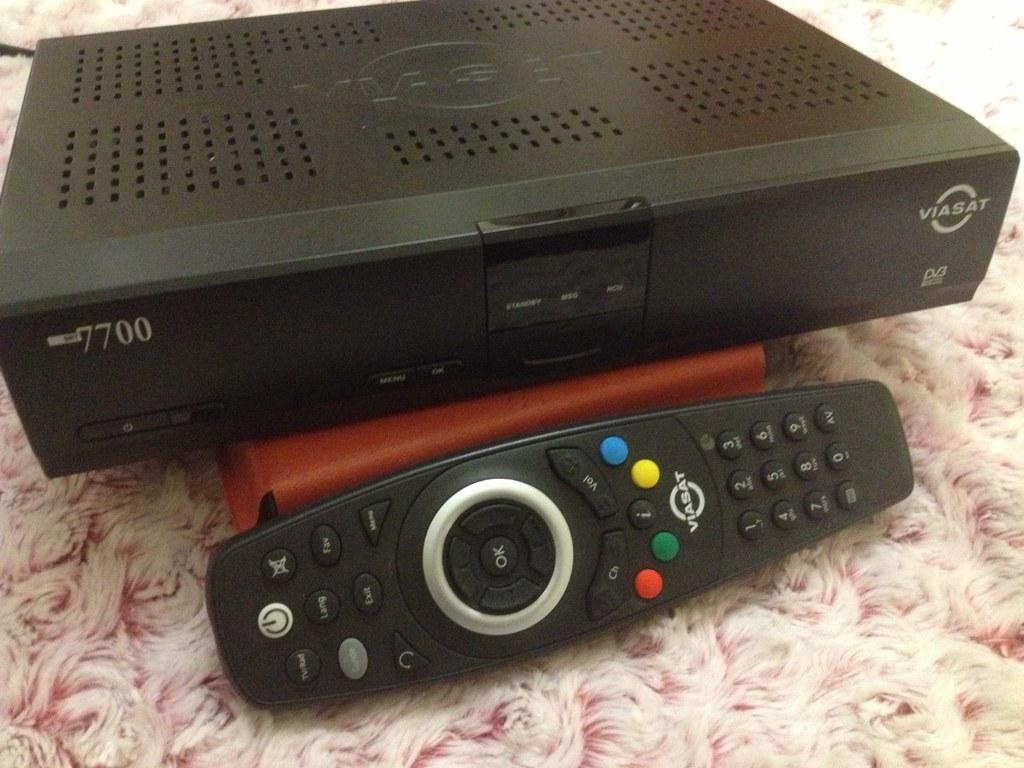<image>
Summarize the visual content of the image. A dvr cable box and remote that goes with it on a pink shag carpet 